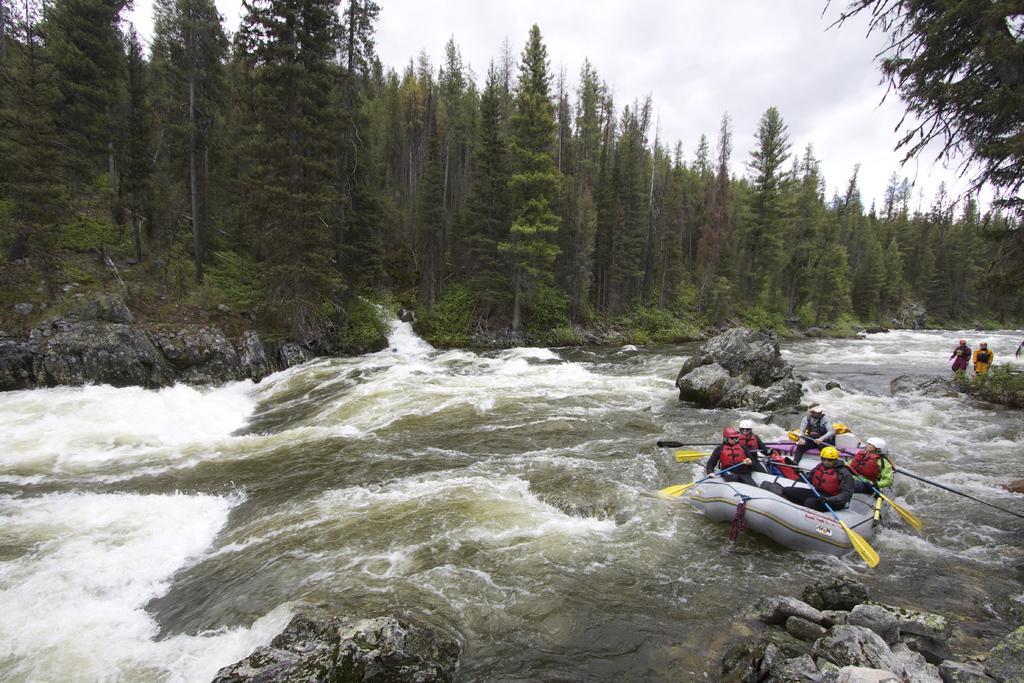Could you give a brief overview of what you see in this image? In this picture we can see a boat on the water with five people wore helmets, holding paddles with their hands, sitting on it and at the back of them we can see two people, rocks, trees and in the background we can see the sky. 